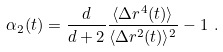Convert formula to latex. <formula><loc_0><loc_0><loc_500><loc_500>\alpha _ { 2 } ( t ) = \frac { d } { d + 2 } \frac { \langle \Delta r ^ { 4 } ( t ) \rangle } { \langle \Delta r ^ { 2 } ( t ) \rangle ^ { 2 } } - 1 \ .</formula> 